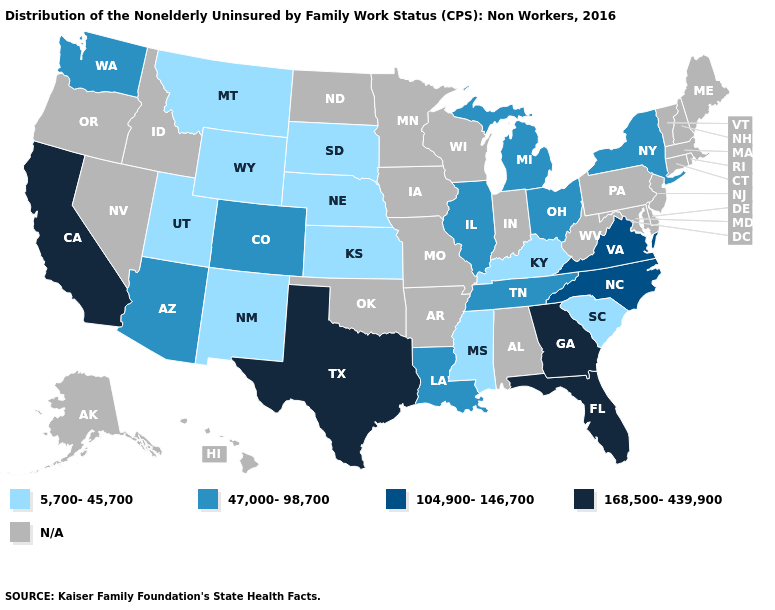What is the value of Iowa?
Quick response, please. N/A. Among the states that border Ohio , which have the highest value?
Give a very brief answer. Michigan. What is the value of Oklahoma?
Write a very short answer. N/A. Does the map have missing data?
Short answer required. Yes. Name the states that have a value in the range 47,000-98,700?
Be succinct. Arizona, Colorado, Illinois, Louisiana, Michigan, New York, Ohio, Tennessee, Washington. Name the states that have a value in the range 104,900-146,700?
Concise answer only. North Carolina, Virginia. What is the value of Montana?
Short answer required. 5,700-45,700. How many symbols are there in the legend?
Give a very brief answer. 5. Which states have the lowest value in the Northeast?
Give a very brief answer. New York. What is the highest value in the USA?
Short answer required. 168,500-439,900. 